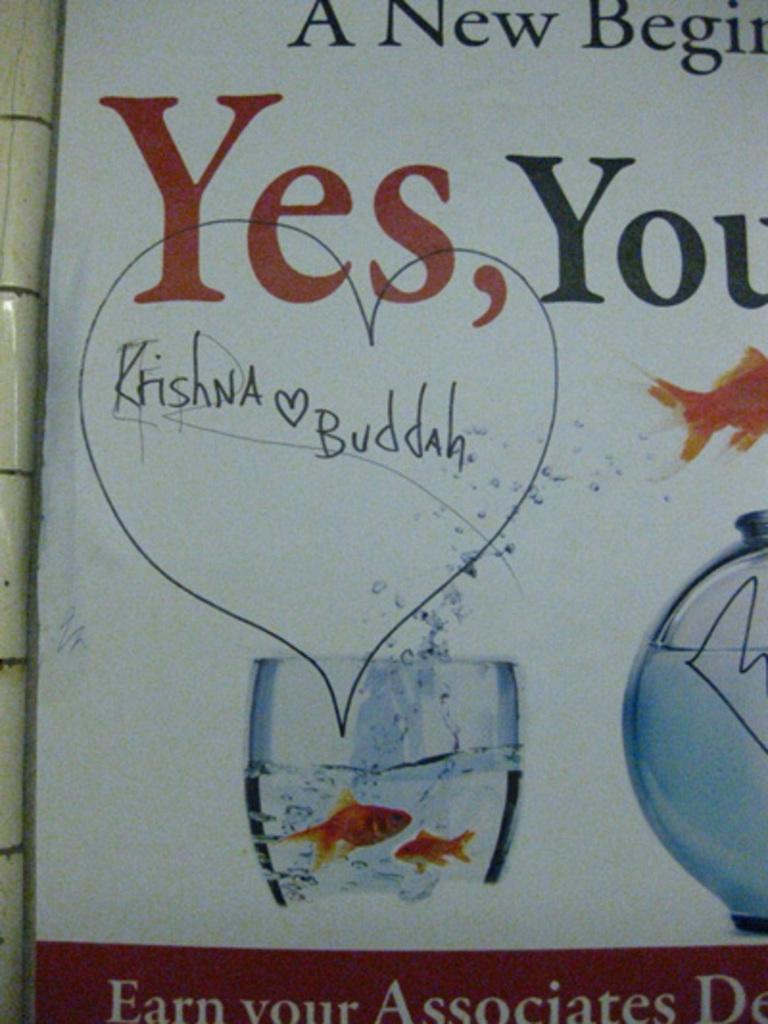How would you summarize this image in a sentence or two? In this image I can see a board on which there are some text and images of a glass bowl and a glass. In the glass there are two fishes in the water. 